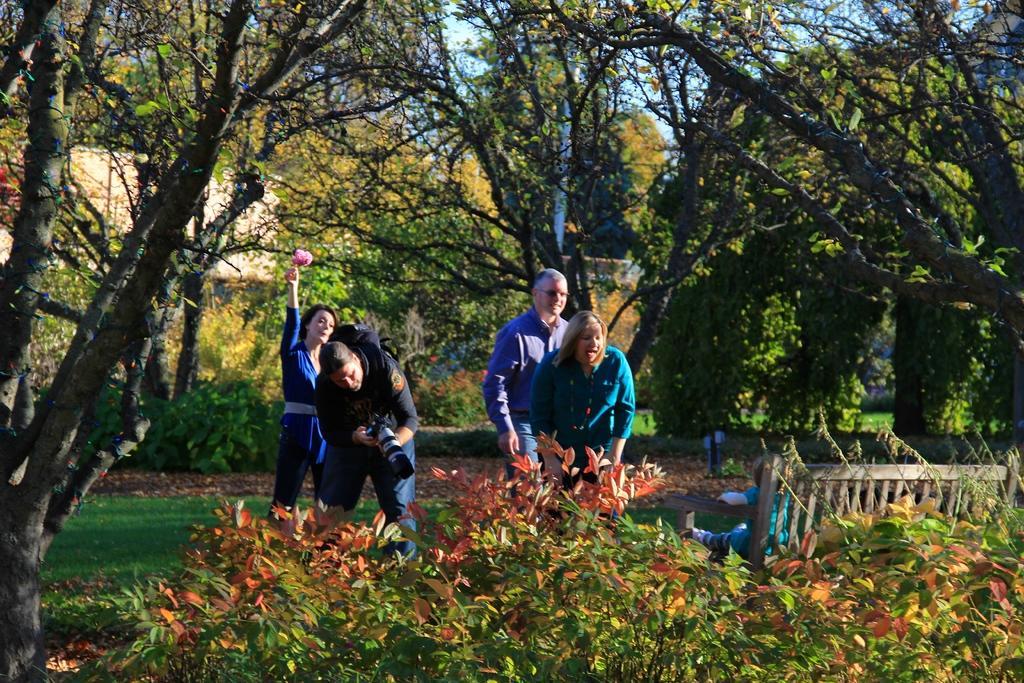In one or two sentences, can you explain what this image depicts? In the foreground of the image we can see plants. In the middle of the image we can see some persons and a small kid is sitting on the bench and one person is taking a photograph of that kid. On the top of the image we can see trees. 